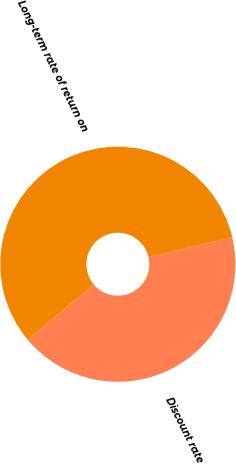Convert chart. <chart><loc_0><loc_0><loc_500><loc_500><pie_chart><fcel>Discount rate<fcel>Long-term rate of return on<nl><fcel>42.59%<fcel>57.41%<nl></chart> 